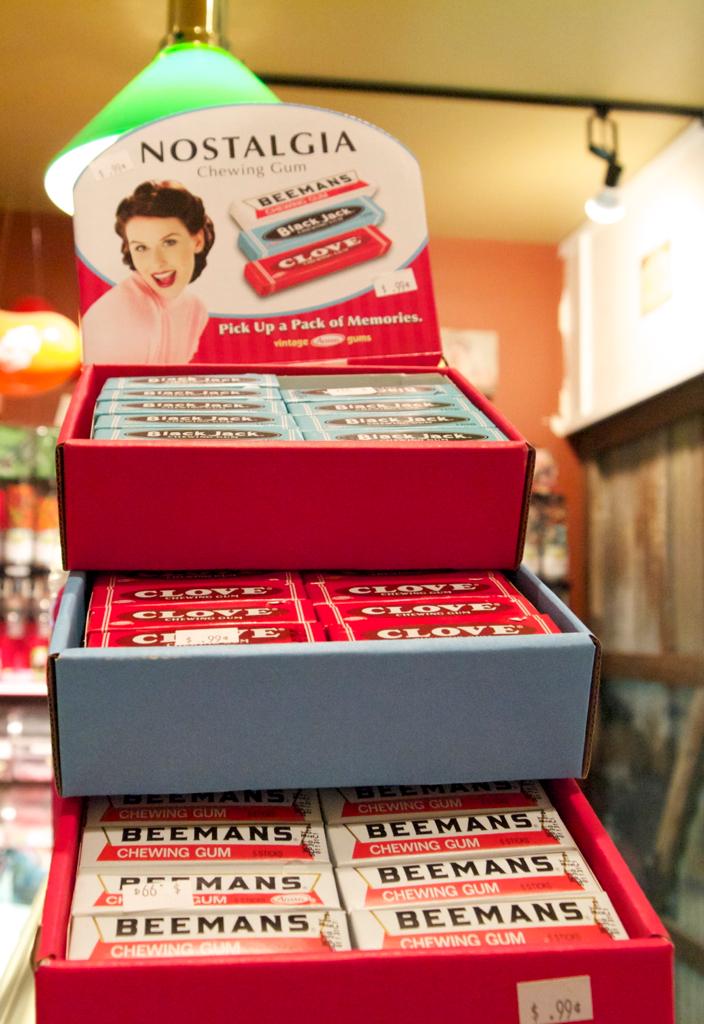What brands of gum is this?
Keep it short and to the point. Nostalgia. What is wrote on the chewing gum in the middle box?
Keep it short and to the point. Clove. 